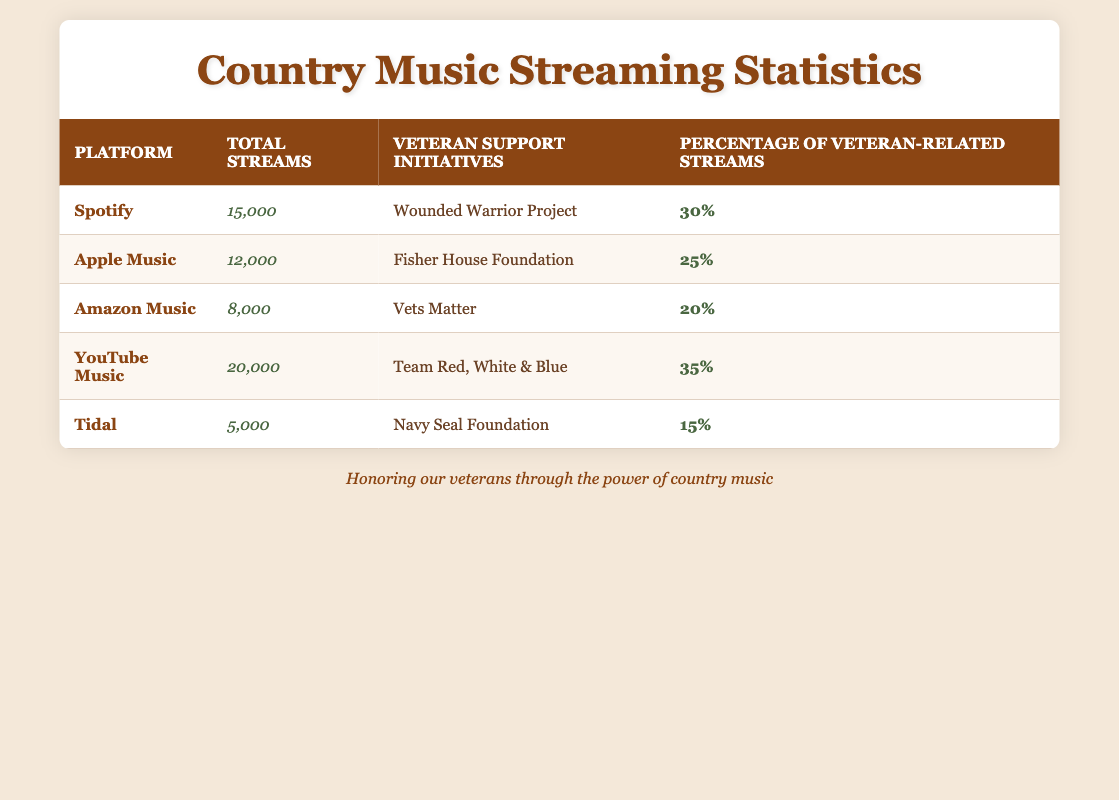What is the total number of streams for YouTube Music? The total number of streams for YouTube Music is specifically listed in the table under the 'Total Streams' column, which reads 20,000.
Answer: 20,000 Which platform has the highest percentage of streams for veteran-related songs? By comparing the 'Percentage of Streams for Veteran-Related Songs' column, YouTube Music has the highest percentage at 35%.
Answer: YouTube Music What is the total number of streams for all platforms combined? To find the total, sum the 'Total Streams' from each platform: 15000 + 12000 + 8000 + 20000 + 5000 = 60000.
Answer: 60000 Is the percentage of veteran-related streams for Amazon Music greater than that for Tidal? The table shows Amazon Music has 20% and Tidal has 15%, so yes, 20% is greater than 15%.
Answer: Yes What is the average percentage of veteran-related streams across all platforms? Calculate the average by summing the percentages: (30 + 25 + 20 + 35 + 15) = 125, and divide by the number of platforms (5): 125 / 5 = 25.
Answer: 25 Which veteran support initiative corresponds to the platform with the least total streams? Tidal has the least total streams at 5,000, and its corresponding initiative is the Navy Seal Foundation.
Answer: Navy Seal Foundation Is the total number of streams highest on Spotify? Spotify has 15,000 streams, but YouTube Music has 20,000 streams, which is higher. So, the statement is false.
Answer: No How many platforms are associated with veteran support initiatives that have a full percentage of streams exceeding 30%? The platforms associated with veteran-related songs exceeding 30% are YouTube Music (35%) and Spotify (30%). Hence there are two platforms in total.
Answer: 2 What is the difference in total streams between YouTube Music and Tidal? YouTube Music has 20,000 streams and Tidal has 5,000 streams. The difference is 20,000 - 5,000 = 15,000.
Answer: 15,000 